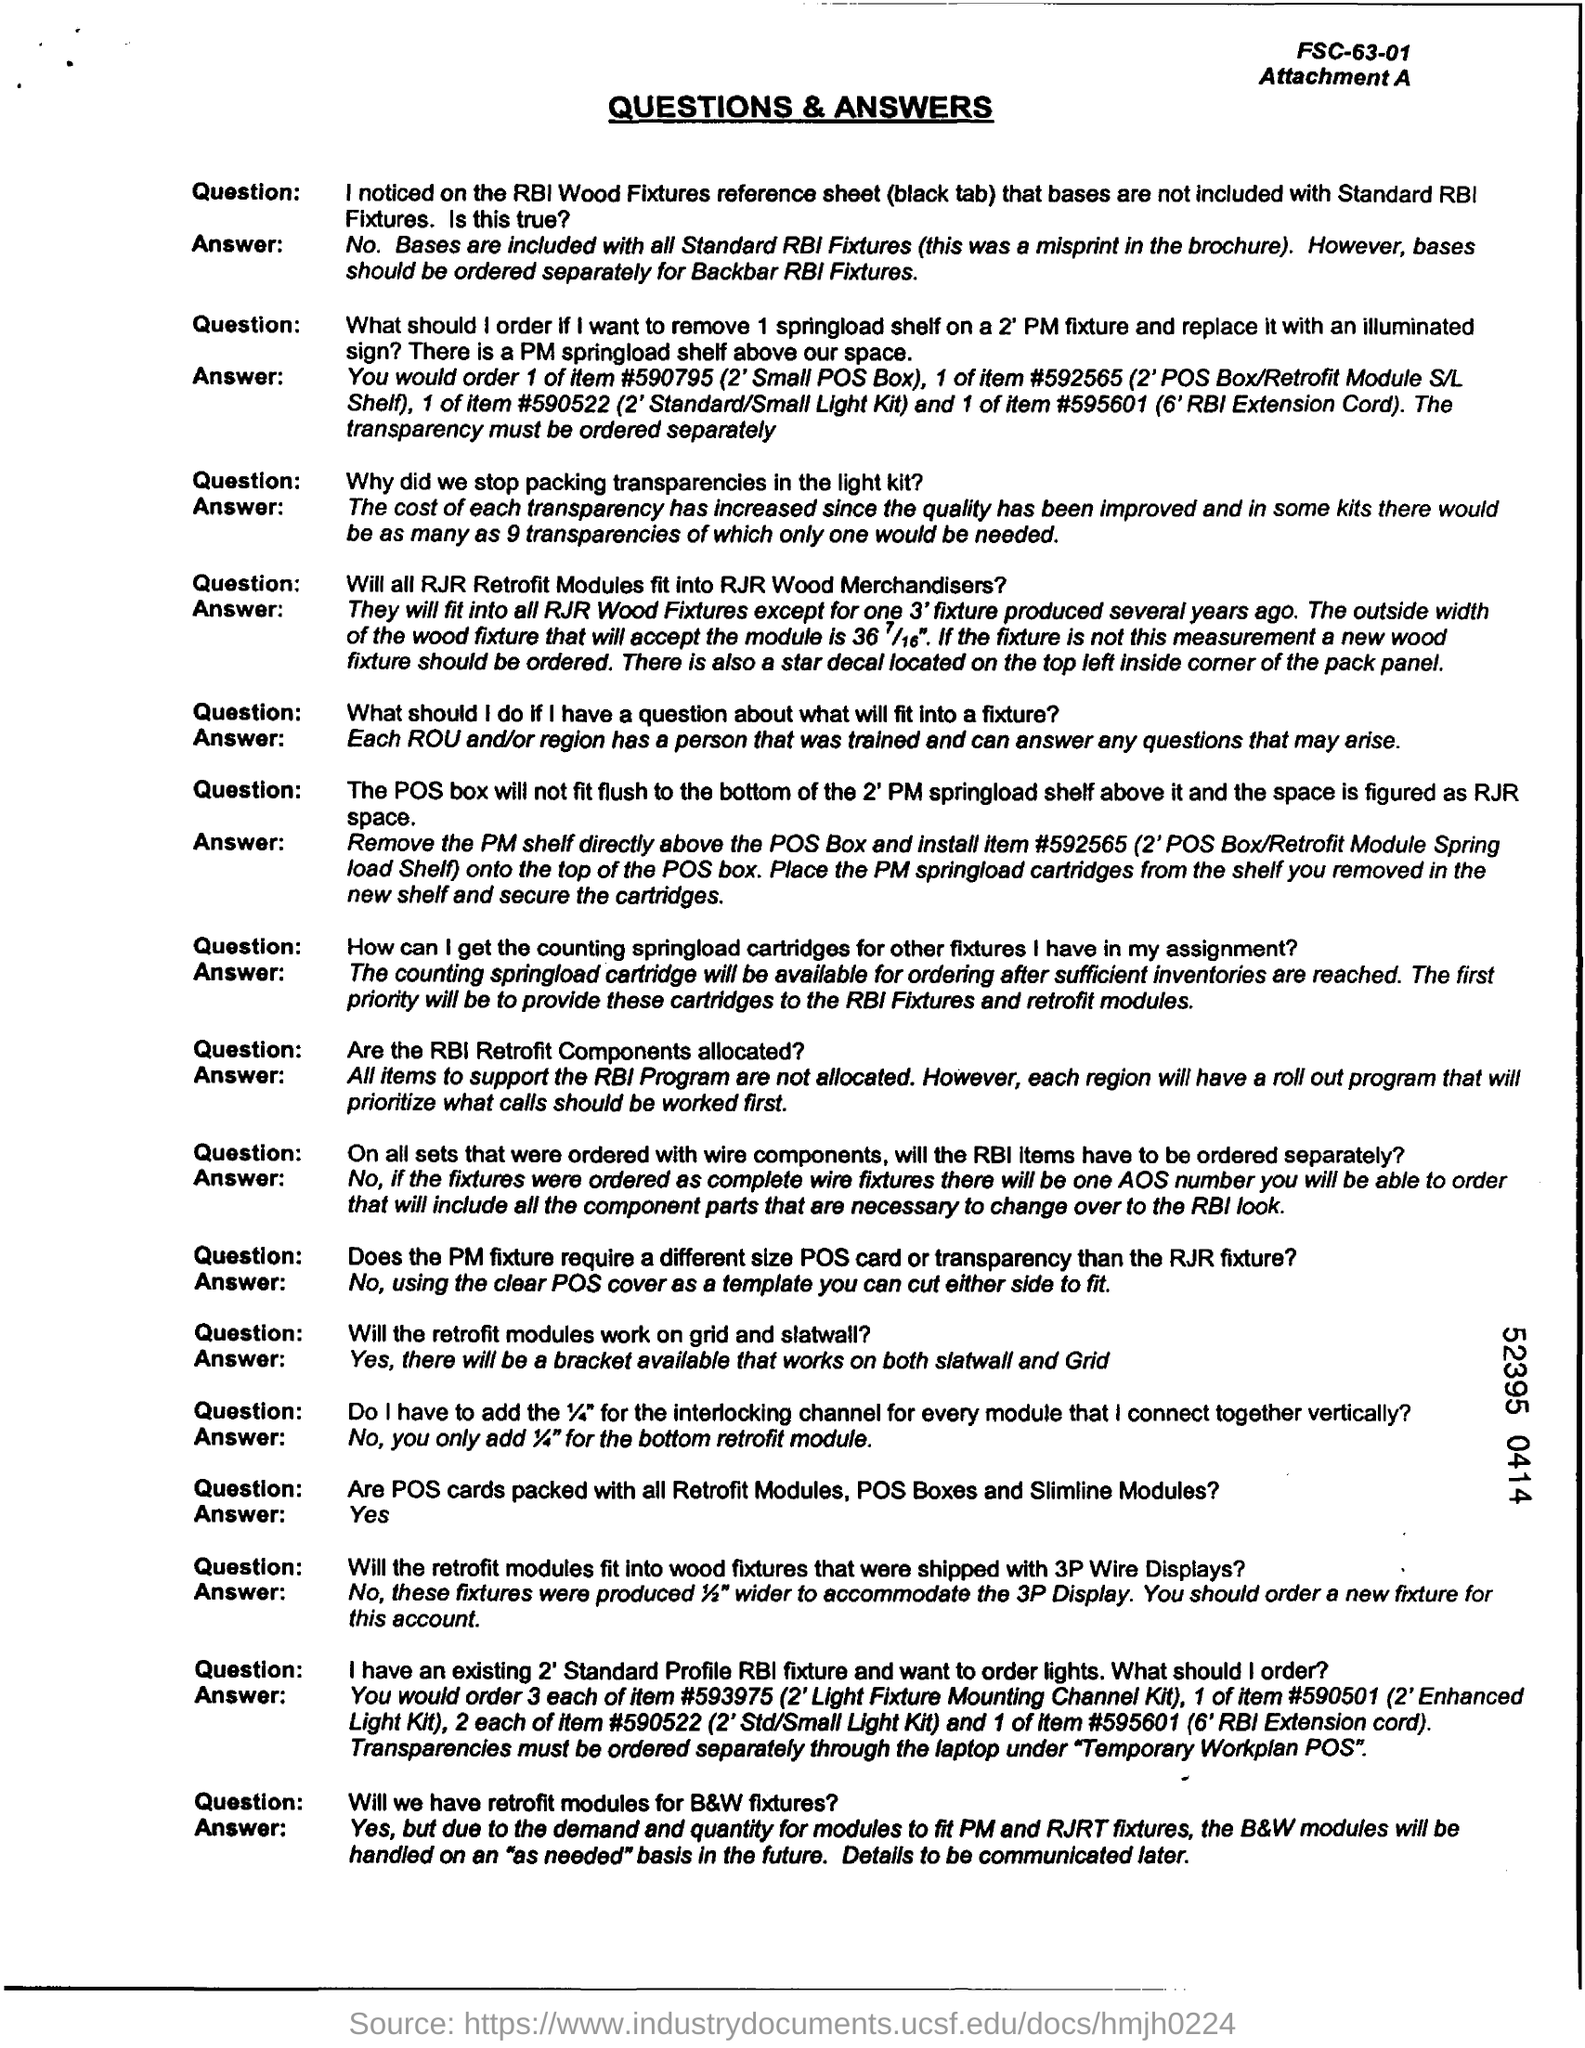Specify some key components in this picture. The title of the document is "Questions & Answers". 